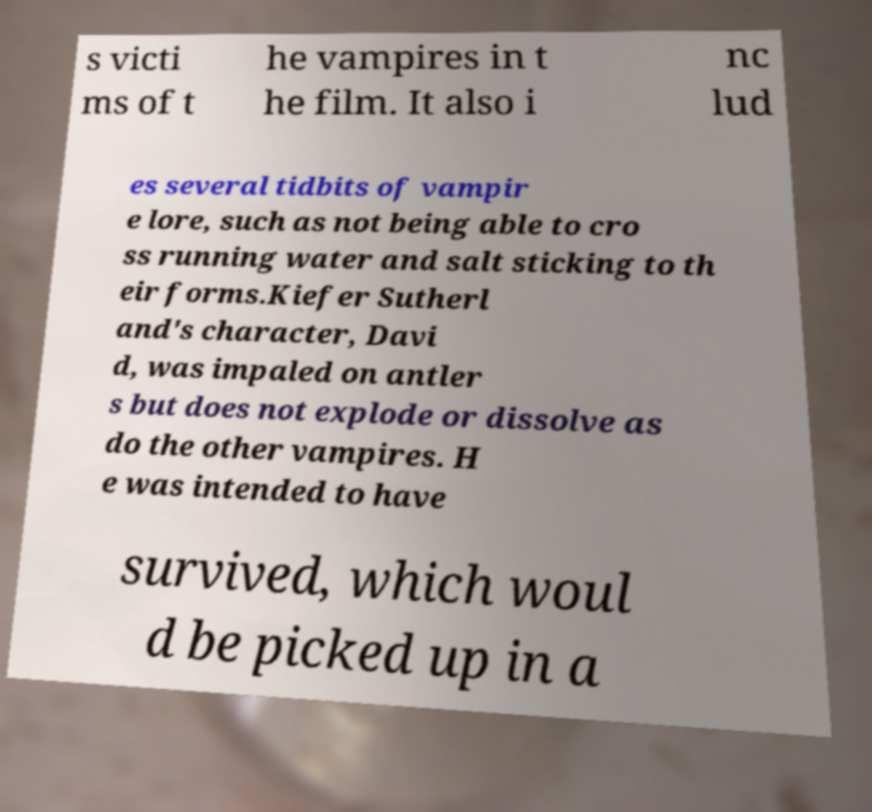Please read and relay the text visible in this image. What does it say? s victi ms of t he vampires in t he film. It also i nc lud es several tidbits of vampir e lore, such as not being able to cro ss running water and salt sticking to th eir forms.Kiefer Sutherl and's character, Davi d, was impaled on antler s but does not explode or dissolve as do the other vampires. H e was intended to have survived, which woul d be picked up in a 